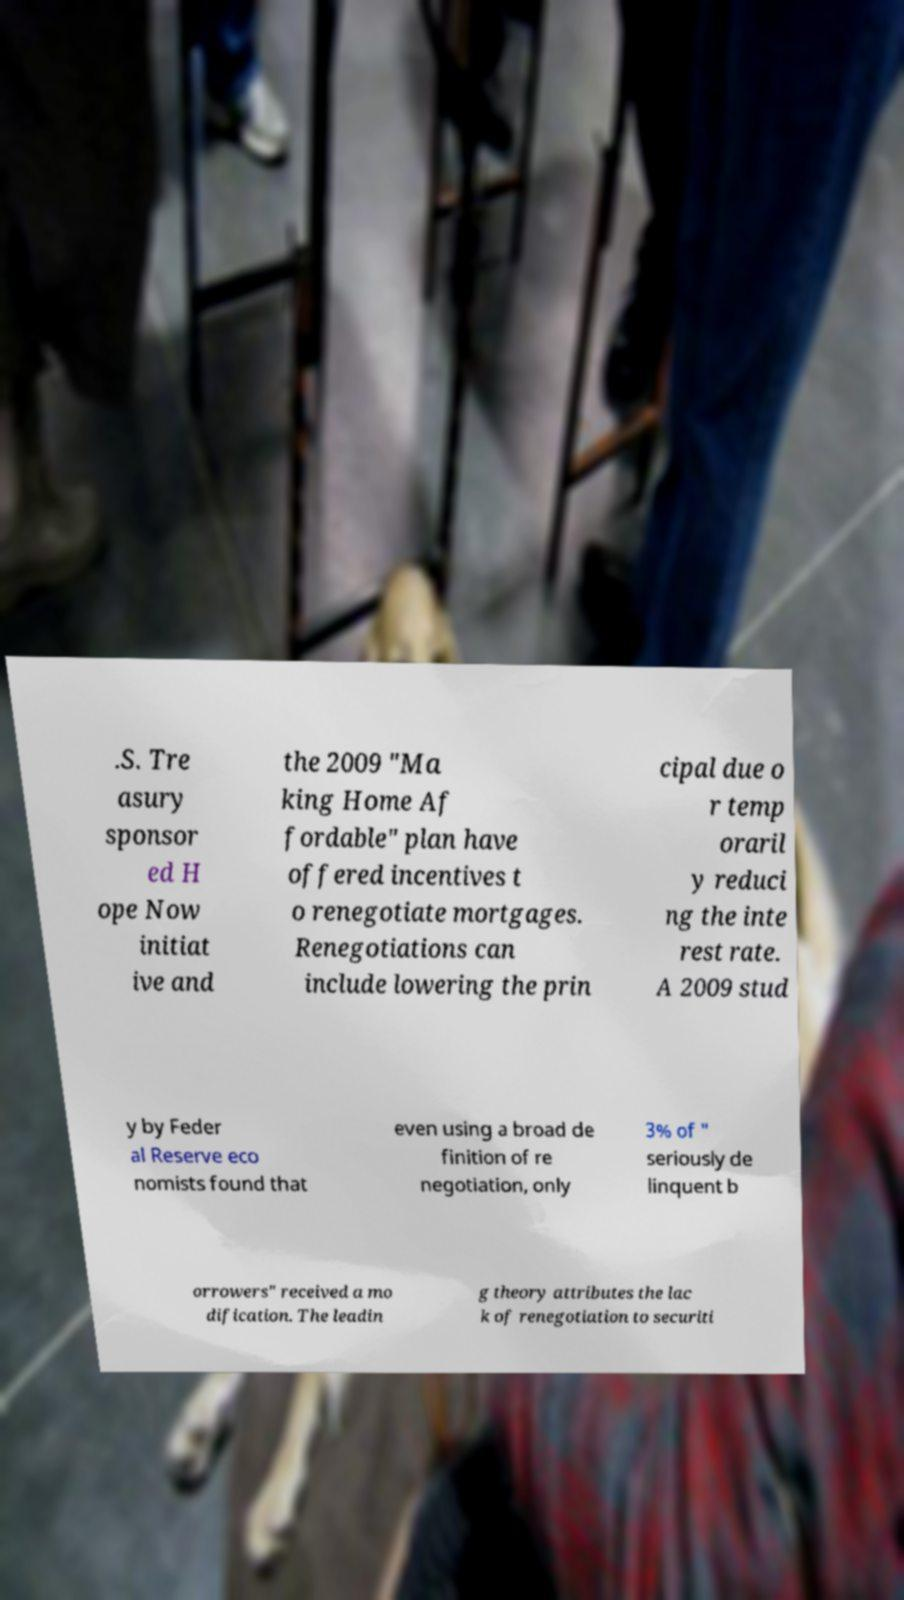Can you read and provide the text displayed in the image?This photo seems to have some interesting text. Can you extract and type it out for me? .S. Tre asury sponsor ed H ope Now initiat ive and the 2009 "Ma king Home Af fordable" plan have offered incentives t o renegotiate mortgages. Renegotiations can include lowering the prin cipal due o r temp oraril y reduci ng the inte rest rate. A 2009 stud y by Feder al Reserve eco nomists found that even using a broad de finition of re negotiation, only 3% of " seriously de linquent b orrowers" received a mo dification. The leadin g theory attributes the lac k of renegotiation to securiti 